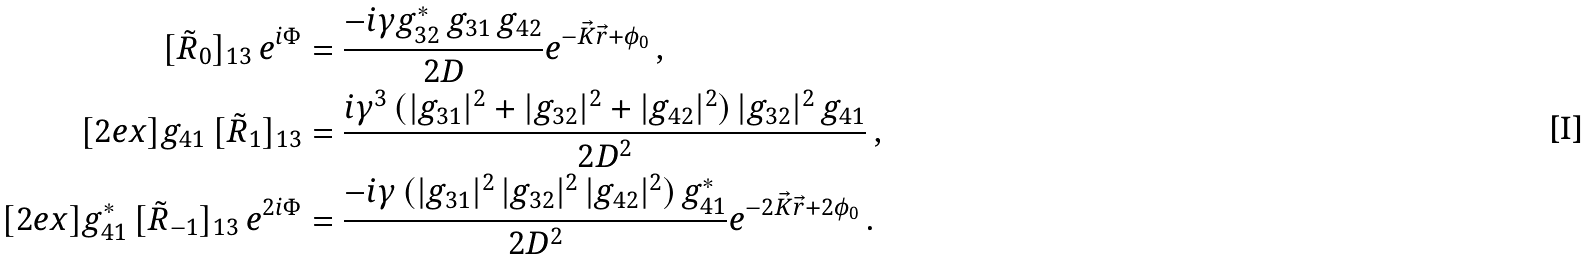<formula> <loc_0><loc_0><loc_500><loc_500>[ \tilde { R } _ { 0 } ] _ { 1 3 } \, e ^ { i \Phi } & = \frac { - i \gamma g _ { 3 2 } ^ { \ast } \, g _ { 3 1 } \, g _ { 4 2 } } { 2 D } e ^ { - \vec { K } \vec { r } + \phi _ { 0 } } \, , \\ [ 2 e x ] g _ { 4 1 } \, [ \tilde { R } _ { 1 } ] _ { 1 3 } & = \frac { i \gamma ^ { 3 } \, ( | g _ { 3 1 } | ^ { 2 } + | g _ { 3 2 } | ^ { 2 } + | g _ { 4 2 } | ^ { 2 } ) \, | g _ { 3 2 } | ^ { 2 } \, g _ { 4 1 } } { 2 D ^ { 2 } } \, , \\ [ 2 e x ] g _ { 4 1 } ^ { \ast } \, [ \tilde { R } _ { - 1 } ] _ { 1 3 } \, e ^ { 2 i \Phi } & = \frac { - i \gamma \, ( | g _ { 3 1 } | ^ { 2 } \, | g _ { 3 2 } | ^ { 2 } \, | g _ { 4 2 } | ^ { 2 } ) \, g _ { 4 1 } ^ { \ast } } { 2 D ^ { 2 } } e ^ { - 2 \vec { K } \vec { r } + 2 \phi _ { 0 } } \, .</formula> 